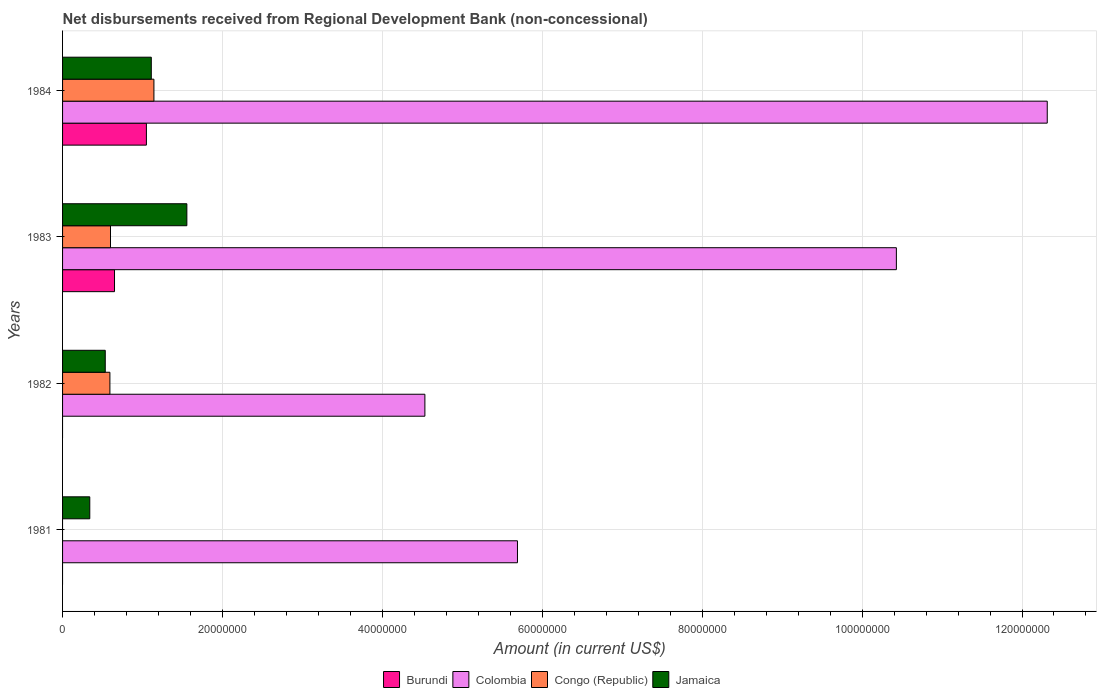How many different coloured bars are there?
Your answer should be compact. 4. How many groups of bars are there?
Offer a terse response. 4. Are the number of bars per tick equal to the number of legend labels?
Offer a terse response. No. What is the label of the 2nd group of bars from the top?
Ensure brevity in your answer.  1983. What is the amount of disbursements received from Regional Development Bank in Colombia in 1984?
Give a very brief answer. 1.23e+08. Across all years, what is the maximum amount of disbursements received from Regional Development Bank in Colombia?
Your answer should be compact. 1.23e+08. What is the total amount of disbursements received from Regional Development Bank in Congo (Republic) in the graph?
Make the answer very short. 2.33e+07. What is the difference between the amount of disbursements received from Regional Development Bank in Jamaica in 1981 and that in 1983?
Provide a succinct answer. -1.21e+07. What is the difference between the amount of disbursements received from Regional Development Bank in Congo (Republic) in 1983 and the amount of disbursements received from Regional Development Bank in Colombia in 1982?
Offer a very short reply. -3.93e+07. What is the average amount of disbursements received from Regional Development Bank in Congo (Republic) per year?
Provide a succinct answer. 5.84e+06. In the year 1984, what is the difference between the amount of disbursements received from Regional Development Bank in Jamaica and amount of disbursements received from Regional Development Bank in Burundi?
Your answer should be compact. 6.10e+05. In how many years, is the amount of disbursements received from Regional Development Bank in Burundi greater than 116000000 US$?
Keep it short and to the point. 0. What is the ratio of the amount of disbursements received from Regional Development Bank in Jamaica in 1981 to that in 1982?
Give a very brief answer. 0.64. What is the difference between the highest and the second highest amount of disbursements received from Regional Development Bank in Jamaica?
Your response must be concise. 4.45e+06. What is the difference between the highest and the lowest amount of disbursements received from Regional Development Bank in Congo (Republic)?
Your response must be concise. 1.14e+07. How many years are there in the graph?
Provide a succinct answer. 4. What is the difference between two consecutive major ticks on the X-axis?
Offer a very short reply. 2.00e+07. Are the values on the major ticks of X-axis written in scientific E-notation?
Provide a succinct answer. No. Where does the legend appear in the graph?
Your response must be concise. Bottom center. What is the title of the graph?
Keep it short and to the point. Net disbursements received from Regional Development Bank (non-concessional). What is the Amount (in current US$) of Colombia in 1981?
Your response must be concise. 5.69e+07. What is the Amount (in current US$) in Congo (Republic) in 1981?
Your answer should be very brief. 0. What is the Amount (in current US$) of Jamaica in 1981?
Make the answer very short. 3.40e+06. What is the Amount (in current US$) in Colombia in 1982?
Offer a terse response. 4.53e+07. What is the Amount (in current US$) in Congo (Republic) in 1982?
Your answer should be compact. 5.92e+06. What is the Amount (in current US$) of Jamaica in 1982?
Your answer should be compact. 5.34e+06. What is the Amount (in current US$) of Burundi in 1983?
Provide a succinct answer. 6.50e+06. What is the Amount (in current US$) of Colombia in 1983?
Offer a terse response. 1.04e+08. What is the Amount (in current US$) in Congo (Republic) in 1983?
Provide a succinct answer. 6.00e+06. What is the Amount (in current US$) in Jamaica in 1983?
Your answer should be compact. 1.55e+07. What is the Amount (in current US$) in Burundi in 1984?
Ensure brevity in your answer.  1.05e+07. What is the Amount (in current US$) of Colombia in 1984?
Provide a succinct answer. 1.23e+08. What is the Amount (in current US$) of Congo (Republic) in 1984?
Keep it short and to the point. 1.14e+07. What is the Amount (in current US$) of Jamaica in 1984?
Make the answer very short. 1.11e+07. Across all years, what is the maximum Amount (in current US$) in Burundi?
Make the answer very short. 1.05e+07. Across all years, what is the maximum Amount (in current US$) of Colombia?
Ensure brevity in your answer.  1.23e+08. Across all years, what is the maximum Amount (in current US$) of Congo (Republic)?
Your answer should be very brief. 1.14e+07. Across all years, what is the maximum Amount (in current US$) in Jamaica?
Provide a short and direct response. 1.55e+07. Across all years, what is the minimum Amount (in current US$) of Burundi?
Ensure brevity in your answer.  0. Across all years, what is the minimum Amount (in current US$) of Colombia?
Provide a succinct answer. 4.53e+07. Across all years, what is the minimum Amount (in current US$) of Congo (Republic)?
Make the answer very short. 0. Across all years, what is the minimum Amount (in current US$) of Jamaica?
Offer a very short reply. 3.40e+06. What is the total Amount (in current US$) of Burundi in the graph?
Offer a very short reply. 1.70e+07. What is the total Amount (in current US$) of Colombia in the graph?
Your answer should be compact. 3.30e+08. What is the total Amount (in current US$) of Congo (Republic) in the graph?
Give a very brief answer. 2.33e+07. What is the total Amount (in current US$) of Jamaica in the graph?
Your answer should be compact. 3.54e+07. What is the difference between the Amount (in current US$) of Colombia in 1981 and that in 1982?
Make the answer very short. 1.16e+07. What is the difference between the Amount (in current US$) of Jamaica in 1981 and that in 1982?
Your answer should be compact. -1.94e+06. What is the difference between the Amount (in current US$) in Colombia in 1981 and that in 1983?
Ensure brevity in your answer.  -4.74e+07. What is the difference between the Amount (in current US$) of Jamaica in 1981 and that in 1983?
Offer a very short reply. -1.21e+07. What is the difference between the Amount (in current US$) in Colombia in 1981 and that in 1984?
Make the answer very short. -6.63e+07. What is the difference between the Amount (in current US$) in Jamaica in 1981 and that in 1984?
Your answer should be very brief. -7.69e+06. What is the difference between the Amount (in current US$) of Colombia in 1982 and that in 1983?
Your answer should be compact. -5.90e+07. What is the difference between the Amount (in current US$) in Congo (Republic) in 1982 and that in 1983?
Offer a very short reply. -7.30e+04. What is the difference between the Amount (in current US$) in Jamaica in 1982 and that in 1983?
Your response must be concise. -1.02e+07. What is the difference between the Amount (in current US$) of Colombia in 1982 and that in 1984?
Make the answer very short. -7.78e+07. What is the difference between the Amount (in current US$) of Congo (Republic) in 1982 and that in 1984?
Give a very brief answer. -5.50e+06. What is the difference between the Amount (in current US$) in Jamaica in 1982 and that in 1984?
Your response must be concise. -5.76e+06. What is the difference between the Amount (in current US$) of Burundi in 1983 and that in 1984?
Offer a very short reply. -3.99e+06. What is the difference between the Amount (in current US$) of Colombia in 1983 and that in 1984?
Your answer should be very brief. -1.89e+07. What is the difference between the Amount (in current US$) of Congo (Republic) in 1983 and that in 1984?
Keep it short and to the point. -5.43e+06. What is the difference between the Amount (in current US$) in Jamaica in 1983 and that in 1984?
Your answer should be compact. 4.45e+06. What is the difference between the Amount (in current US$) in Colombia in 1981 and the Amount (in current US$) in Congo (Republic) in 1982?
Make the answer very short. 5.10e+07. What is the difference between the Amount (in current US$) of Colombia in 1981 and the Amount (in current US$) of Jamaica in 1982?
Your answer should be very brief. 5.16e+07. What is the difference between the Amount (in current US$) in Colombia in 1981 and the Amount (in current US$) in Congo (Republic) in 1983?
Give a very brief answer. 5.09e+07. What is the difference between the Amount (in current US$) in Colombia in 1981 and the Amount (in current US$) in Jamaica in 1983?
Offer a terse response. 4.14e+07. What is the difference between the Amount (in current US$) of Colombia in 1981 and the Amount (in current US$) of Congo (Republic) in 1984?
Keep it short and to the point. 4.55e+07. What is the difference between the Amount (in current US$) of Colombia in 1981 and the Amount (in current US$) of Jamaica in 1984?
Your answer should be very brief. 4.58e+07. What is the difference between the Amount (in current US$) in Colombia in 1982 and the Amount (in current US$) in Congo (Republic) in 1983?
Offer a very short reply. 3.93e+07. What is the difference between the Amount (in current US$) of Colombia in 1982 and the Amount (in current US$) of Jamaica in 1983?
Offer a very short reply. 2.98e+07. What is the difference between the Amount (in current US$) in Congo (Republic) in 1982 and the Amount (in current US$) in Jamaica in 1983?
Make the answer very short. -9.62e+06. What is the difference between the Amount (in current US$) in Colombia in 1982 and the Amount (in current US$) in Congo (Republic) in 1984?
Give a very brief answer. 3.39e+07. What is the difference between the Amount (in current US$) in Colombia in 1982 and the Amount (in current US$) in Jamaica in 1984?
Give a very brief answer. 3.42e+07. What is the difference between the Amount (in current US$) of Congo (Republic) in 1982 and the Amount (in current US$) of Jamaica in 1984?
Your answer should be very brief. -5.18e+06. What is the difference between the Amount (in current US$) of Burundi in 1983 and the Amount (in current US$) of Colombia in 1984?
Your answer should be very brief. -1.17e+08. What is the difference between the Amount (in current US$) of Burundi in 1983 and the Amount (in current US$) of Congo (Republic) in 1984?
Offer a terse response. -4.93e+06. What is the difference between the Amount (in current US$) of Burundi in 1983 and the Amount (in current US$) of Jamaica in 1984?
Keep it short and to the point. -4.60e+06. What is the difference between the Amount (in current US$) of Colombia in 1983 and the Amount (in current US$) of Congo (Republic) in 1984?
Make the answer very short. 9.29e+07. What is the difference between the Amount (in current US$) in Colombia in 1983 and the Amount (in current US$) in Jamaica in 1984?
Provide a short and direct response. 9.32e+07. What is the difference between the Amount (in current US$) of Congo (Republic) in 1983 and the Amount (in current US$) of Jamaica in 1984?
Offer a very short reply. -5.10e+06. What is the average Amount (in current US$) of Burundi per year?
Keep it short and to the point. 4.25e+06. What is the average Amount (in current US$) of Colombia per year?
Keep it short and to the point. 8.24e+07. What is the average Amount (in current US$) in Congo (Republic) per year?
Your response must be concise. 5.84e+06. What is the average Amount (in current US$) of Jamaica per year?
Offer a very short reply. 8.85e+06. In the year 1981, what is the difference between the Amount (in current US$) of Colombia and Amount (in current US$) of Jamaica?
Make the answer very short. 5.35e+07. In the year 1982, what is the difference between the Amount (in current US$) of Colombia and Amount (in current US$) of Congo (Republic)?
Provide a short and direct response. 3.94e+07. In the year 1982, what is the difference between the Amount (in current US$) of Colombia and Amount (in current US$) of Jamaica?
Offer a very short reply. 4.00e+07. In the year 1982, what is the difference between the Amount (in current US$) in Congo (Republic) and Amount (in current US$) in Jamaica?
Offer a very short reply. 5.83e+05. In the year 1983, what is the difference between the Amount (in current US$) of Burundi and Amount (in current US$) of Colombia?
Make the answer very short. -9.78e+07. In the year 1983, what is the difference between the Amount (in current US$) in Burundi and Amount (in current US$) in Congo (Republic)?
Make the answer very short. 5.02e+05. In the year 1983, what is the difference between the Amount (in current US$) of Burundi and Amount (in current US$) of Jamaica?
Make the answer very short. -9.05e+06. In the year 1983, what is the difference between the Amount (in current US$) of Colombia and Amount (in current US$) of Congo (Republic)?
Give a very brief answer. 9.83e+07. In the year 1983, what is the difference between the Amount (in current US$) of Colombia and Amount (in current US$) of Jamaica?
Make the answer very short. 8.87e+07. In the year 1983, what is the difference between the Amount (in current US$) of Congo (Republic) and Amount (in current US$) of Jamaica?
Provide a succinct answer. -9.55e+06. In the year 1984, what is the difference between the Amount (in current US$) of Burundi and Amount (in current US$) of Colombia?
Your answer should be compact. -1.13e+08. In the year 1984, what is the difference between the Amount (in current US$) in Burundi and Amount (in current US$) in Congo (Republic)?
Ensure brevity in your answer.  -9.40e+05. In the year 1984, what is the difference between the Amount (in current US$) of Burundi and Amount (in current US$) of Jamaica?
Give a very brief answer. -6.10e+05. In the year 1984, what is the difference between the Amount (in current US$) in Colombia and Amount (in current US$) in Congo (Republic)?
Provide a short and direct response. 1.12e+08. In the year 1984, what is the difference between the Amount (in current US$) in Colombia and Amount (in current US$) in Jamaica?
Provide a succinct answer. 1.12e+08. What is the ratio of the Amount (in current US$) in Colombia in 1981 to that in 1982?
Provide a succinct answer. 1.26. What is the ratio of the Amount (in current US$) in Jamaica in 1981 to that in 1982?
Offer a terse response. 0.64. What is the ratio of the Amount (in current US$) of Colombia in 1981 to that in 1983?
Make the answer very short. 0.55. What is the ratio of the Amount (in current US$) in Jamaica in 1981 to that in 1983?
Provide a short and direct response. 0.22. What is the ratio of the Amount (in current US$) in Colombia in 1981 to that in 1984?
Provide a short and direct response. 0.46. What is the ratio of the Amount (in current US$) of Jamaica in 1981 to that in 1984?
Give a very brief answer. 0.31. What is the ratio of the Amount (in current US$) in Colombia in 1982 to that in 1983?
Ensure brevity in your answer.  0.43. What is the ratio of the Amount (in current US$) of Jamaica in 1982 to that in 1983?
Provide a short and direct response. 0.34. What is the ratio of the Amount (in current US$) in Colombia in 1982 to that in 1984?
Give a very brief answer. 0.37. What is the ratio of the Amount (in current US$) of Congo (Republic) in 1982 to that in 1984?
Provide a succinct answer. 0.52. What is the ratio of the Amount (in current US$) of Jamaica in 1982 to that in 1984?
Your answer should be compact. 0.48. What is the ratio of the Amount (in current US$) of Burundi in 1983 to that in 1984?
Ensure brevity in your answer.  0.62. What is the ratio of the Amount (in current US$) in Colombia in 1983 to that in 1984?
Give a very brief answer. 0.85. What is the ratio of the Amount (in current US$) of Congo (Republic) in 1983 to that in 1984?
Ensure brevity in your answer.  0.52. What is the ratio of the Amount (in current US$) in Jamaica in 1983 to that in 1984?
Give a very brief answer. 1.4. What is the difference between the highest and the second highest Amount (in current US$) in Colombia?
Keep it short and to the point. 1.89e+07. What is the difference between the highest and the second highest Amount (in current US$) of Congo (Republic)?
Provide a short and direct response. 5.43e+06. What is the difference between the highest and the second highest Amount (in current US$) in Jamaica?
Make the answer very short. 4.45e+06. What is the difference between the highest and the lowest Amount (in current US$) in Burundi?
Your response must be concise. 1.05e+07. What is the difference between the highest and the lowest Amount (in current US$) of Colombia?
Provide a short and direct response. 7.78e+07. What is the difference between the highest and the lowest Amount (in current US$) in Congo (Republic)?
Keep it short and to the point. 1.14e+07. What is the difference between the highest and the lowest Amount (in current US$) of Jamaica?
Your answer should be very brief. 1.21e+07. 